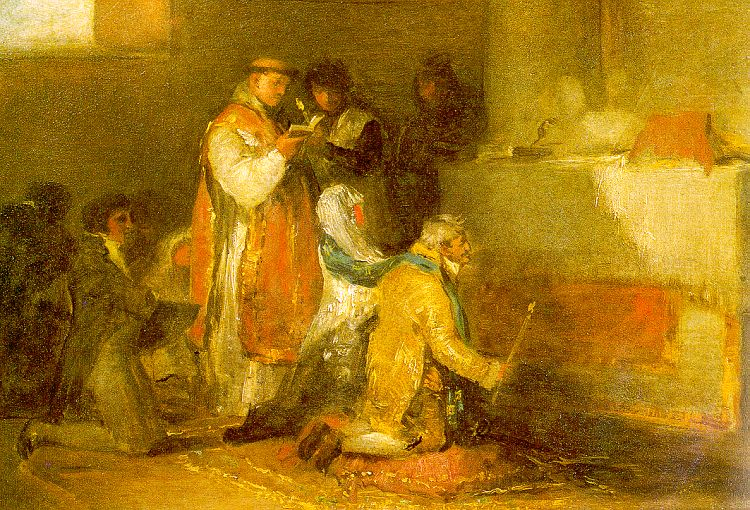Imagine the story behind this scene. What could be happening here? In this scene, one could imagine a quiet afternoon in the late 19th century within a small chapel or private room arranged for prayer. The person in the red robe might be a priest or an elder conducting a reading or a prayer session, guiding the people around them. The individual kneeling in yellow could be seeking guidance or performing a ritual of repentance or reflection. This scene possibly captures a routine moment of devotion, highlighting the simple yet profound customs that played a significant role in the daily lives of the people depicted. 